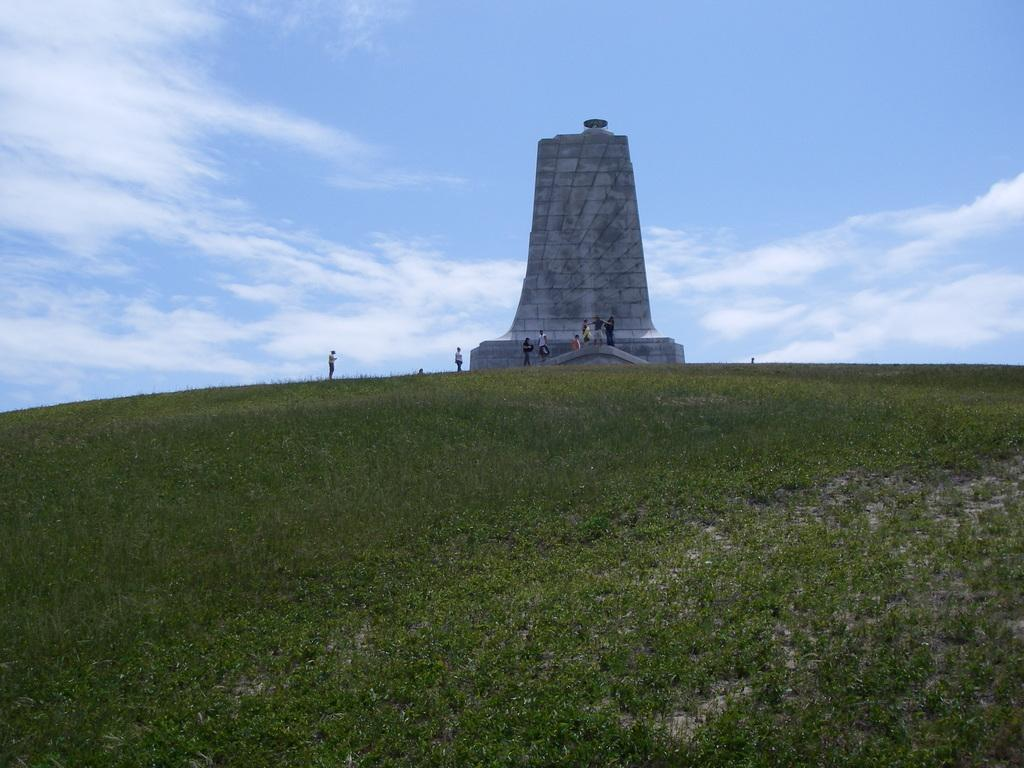What type of vegetation is present in the image? There is grass in the image. What can be seen in the image that resembles a monument? There is a structure that resembles a monument in the image. What are the people near the monument doing? The people standing near the monument are visible in the image. What is visible in the background of the image? The sky is visible in the background of the image. What can be observed about the sky in the image? There are clouds in the sky. What purpose does the note serve in the image? There is no note present in the image. Can you describe how the people are pulling the monument in the image? The people are not pulling the monument in the image; they are simply standing near it. 